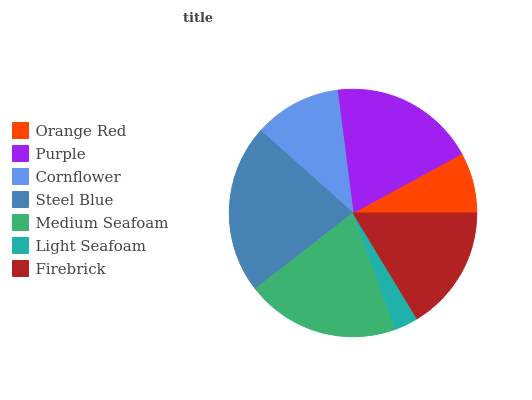Is Light Seafoam the minimum?
Answer yes or no. Yes. Is Steel Blue the maximum?
Answer yes or no. Yes. Is Purple the minimum?
Answer yes or no. No. Is Purple the maximum?
Answer yes or no. No. Is Purple greater than Orange Red?
Answer yes or no. Yes. Is Orange Red less than Purple?
Answer yes or no. Yes. Is Orange Red greater than Purple?
Answer yes or no. No. Is Purple less than Orange Red?
Answer yes or no. No. Is Firebrick the high median?
Answer yes or no. Yes. Is Firebrick the low median?
Answer yes or no. Yes. Is Medium Seafoam the high median?
Answer yes or no. No. Is Orange Red the low median?
Answer yes or no. No. 